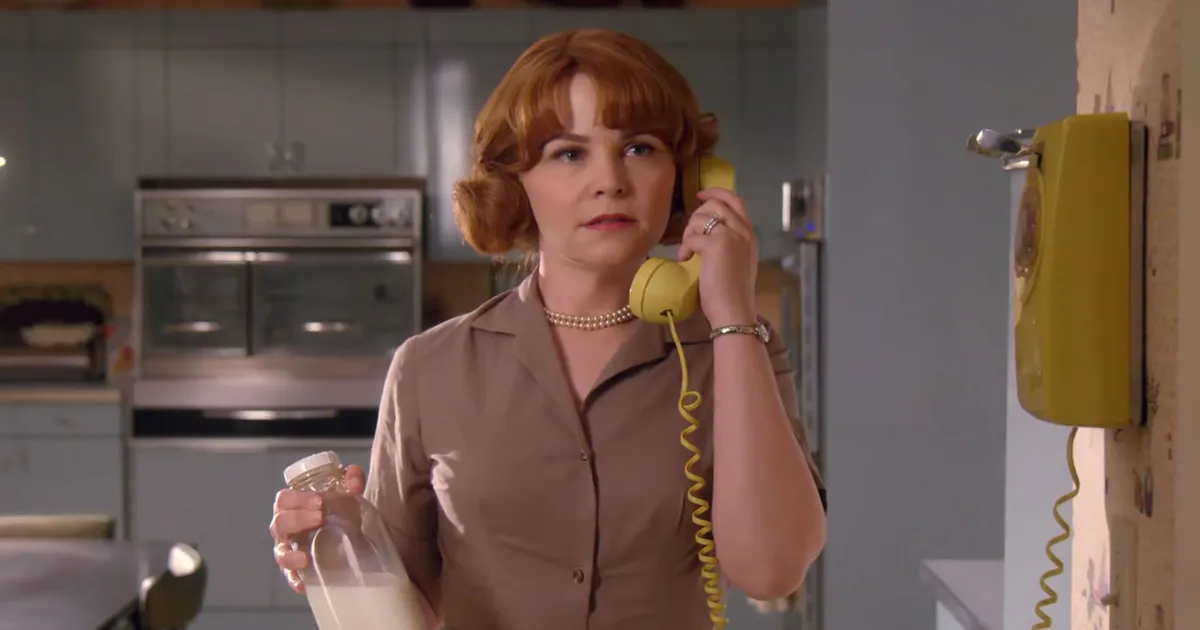How does the woman's attire contribute to the image's story? Her attire, which includes a beige dress and a pearl necklace, complements the vintage feel of the kitchen. These details may hint at a particular role or routine, possibly as a homemaker or someone who takes pleasure in traditional attire and domestic activities. The elements work together to tell a story of a time when such clothing and roles were more common. What details can you infer about the time period of this setting? Details like the rotary phone, the style of the milk bottle, and the kitchen appliances suggest the picture is set around the 1950s to 1960s. These elements, combined with her hairdo and outfit, strongly evoke the mid-20th century, a time characterized by distinctive design choices and specific social norms. 